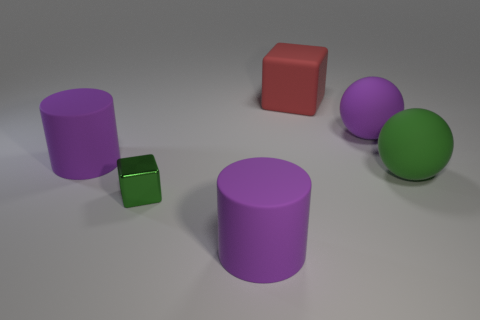Does the large sphere behind the large green rubber ball have the same color as the small cube?
Offer a terse response. No. Do the rubber block and the block in front of the big red rubber cube have the same color?
Give a very brief answer. No. Are there any red rubber cubes left of the small green metal cube?
Offer a terse response. No. Is the material of the big green thing the same as the tiny green block?
Offer a terse response. No. There is a green thing that is the same size as the red matte thing; what is its material?
Ensure brevity in your answer.  Rubber. What number of objects are either purple cylinders that are right of the shiny thing or green shiny cubes?
Ensure brevity in your answer.  2. Are there an equal number of large cubes that are behind the large block and green metallic balls?
Your answer should be very brief. Yes. Does the small thing have the same color as the matte block?
Offer a very short reply. No. There is a large object that is on the left side of the red matte cube and behind the green metal cube; what is its color?
Offer a very short reply. Purple. What number of spheres are either green shiny things or green rubber objects?
Offer a terse response. 1. 